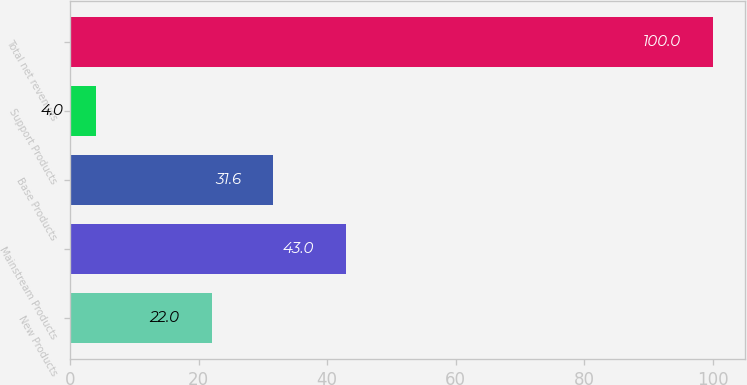<chart> <loc_0><loc_0><loc_500><loc_500><bar_chart><fcel>New Products<fcel>Mainstream Products<fcel>Base Products<fcel>Support Products<fcel>Total net revenues<nl><fcel>22<fcel>43<fcel>31.6<fcel>4<fcel>100<nl></chart> 